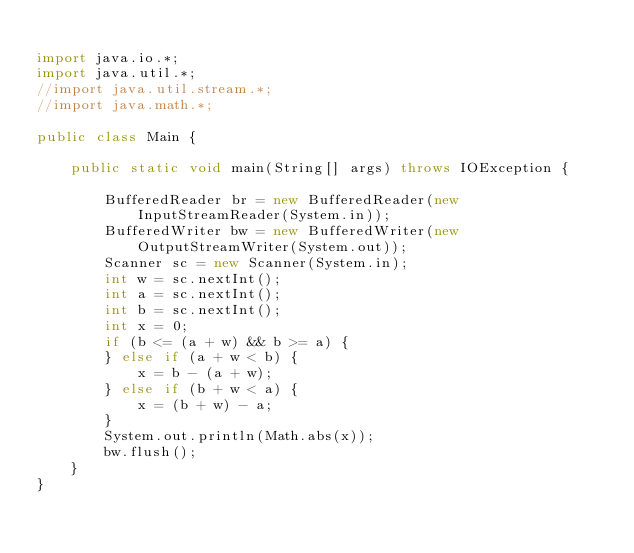Convert code to text. <code><loc_0><loc_0><loc_500><loc_500><_Java_>
import java.io.*;
import java.util.*;
//import java.util.stream.*;
//import java.math.*;

public class Main {

    public static void main(String[] args) throws IOException {

        BufferedReader br = new BufferedReader(new InputStreamReader(System.in));
        BufferedWriter bw = new BufferedWriter(new OutputStreamWriter(System.out));
        Scanner sc = new Scanner(System.in);
        int w = sc.nextInt();
        int a = sc.nextInt();
        int b = sc.nextInt();
        int x = 0;
        if (b <= (a + w) && b >= a) {
        } else if (a + w < b) {
            x = b - (a + w);
        } else if (b + w < a) {
            x = (b + w) - a;
        }
        System.out.println(Math.abs(x));
        bw.flush();
    }
}
</code> 